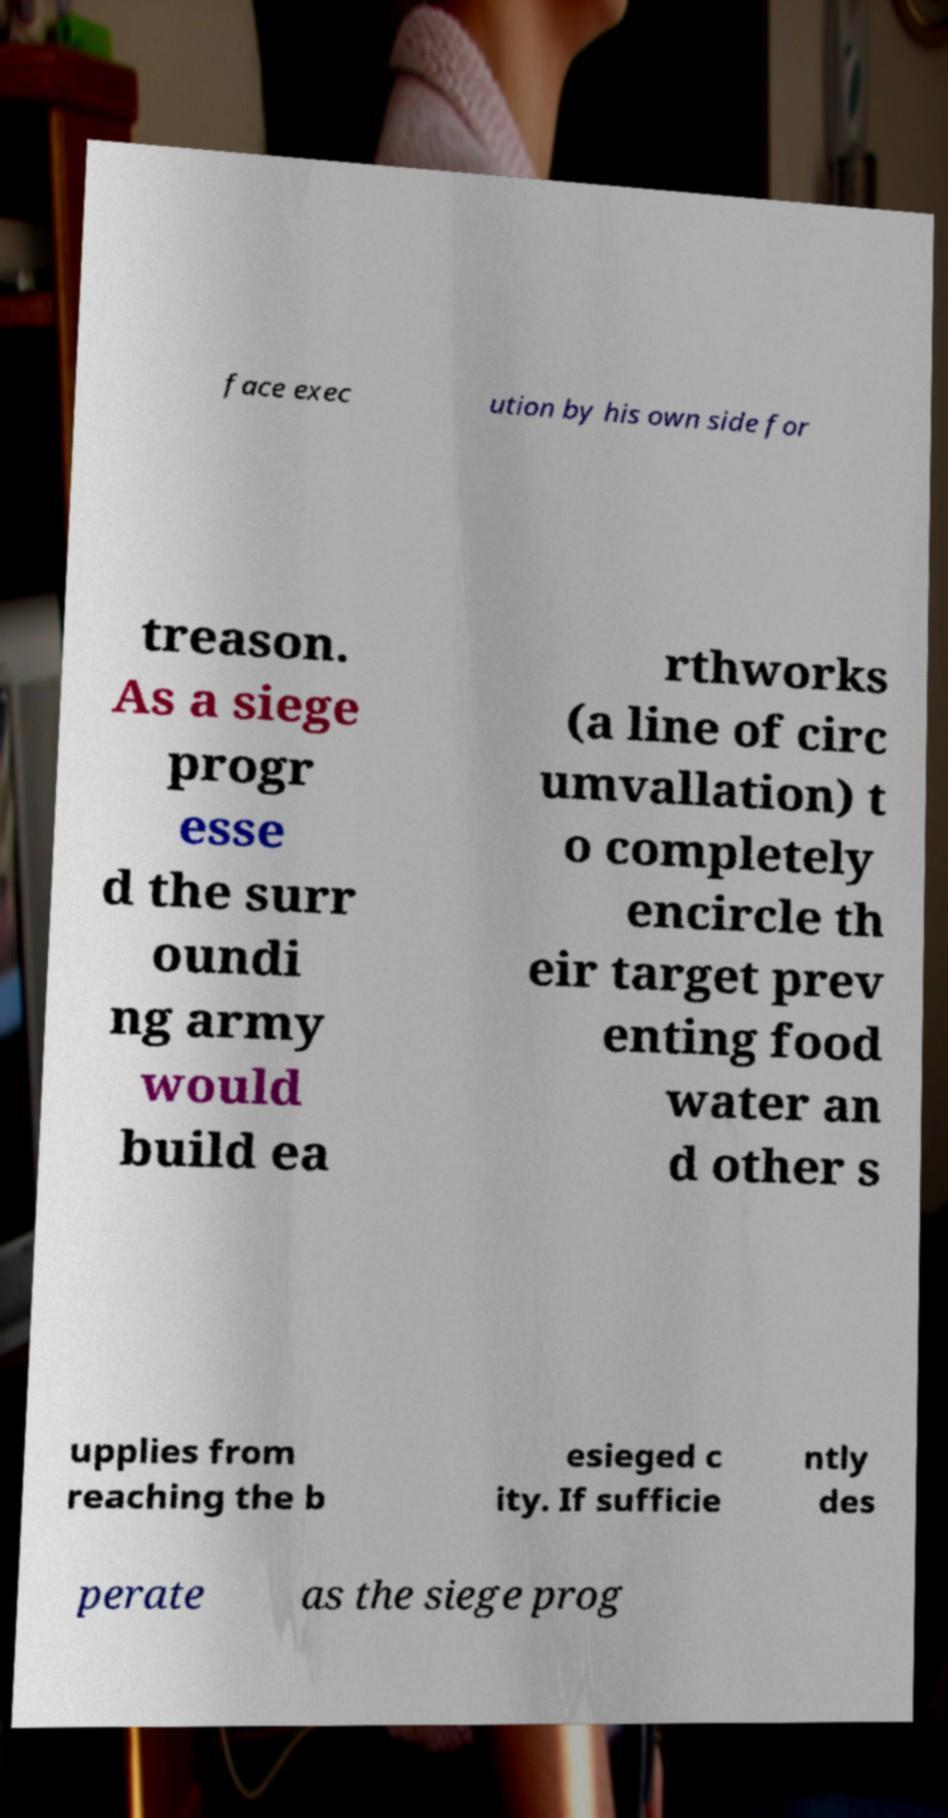For documentation purposes, I need the text within this image transcribed. Could you provide that? face exec ution by his own side for treason. As a siege progr esse d the surr oundi ng army would build ea rthworks (a line of circ umvallation) t o completely encircle th eir target prev enting food water an d other s upplies from reaching the b esieged c ity. If sufficie ntly des perate as the siege prog 